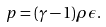Convert formula to latex. <formula><loc_0><loc_0><loc_500><loc_500>p = ( \gamma - 1 ) \rho \epsilon .</formula> 